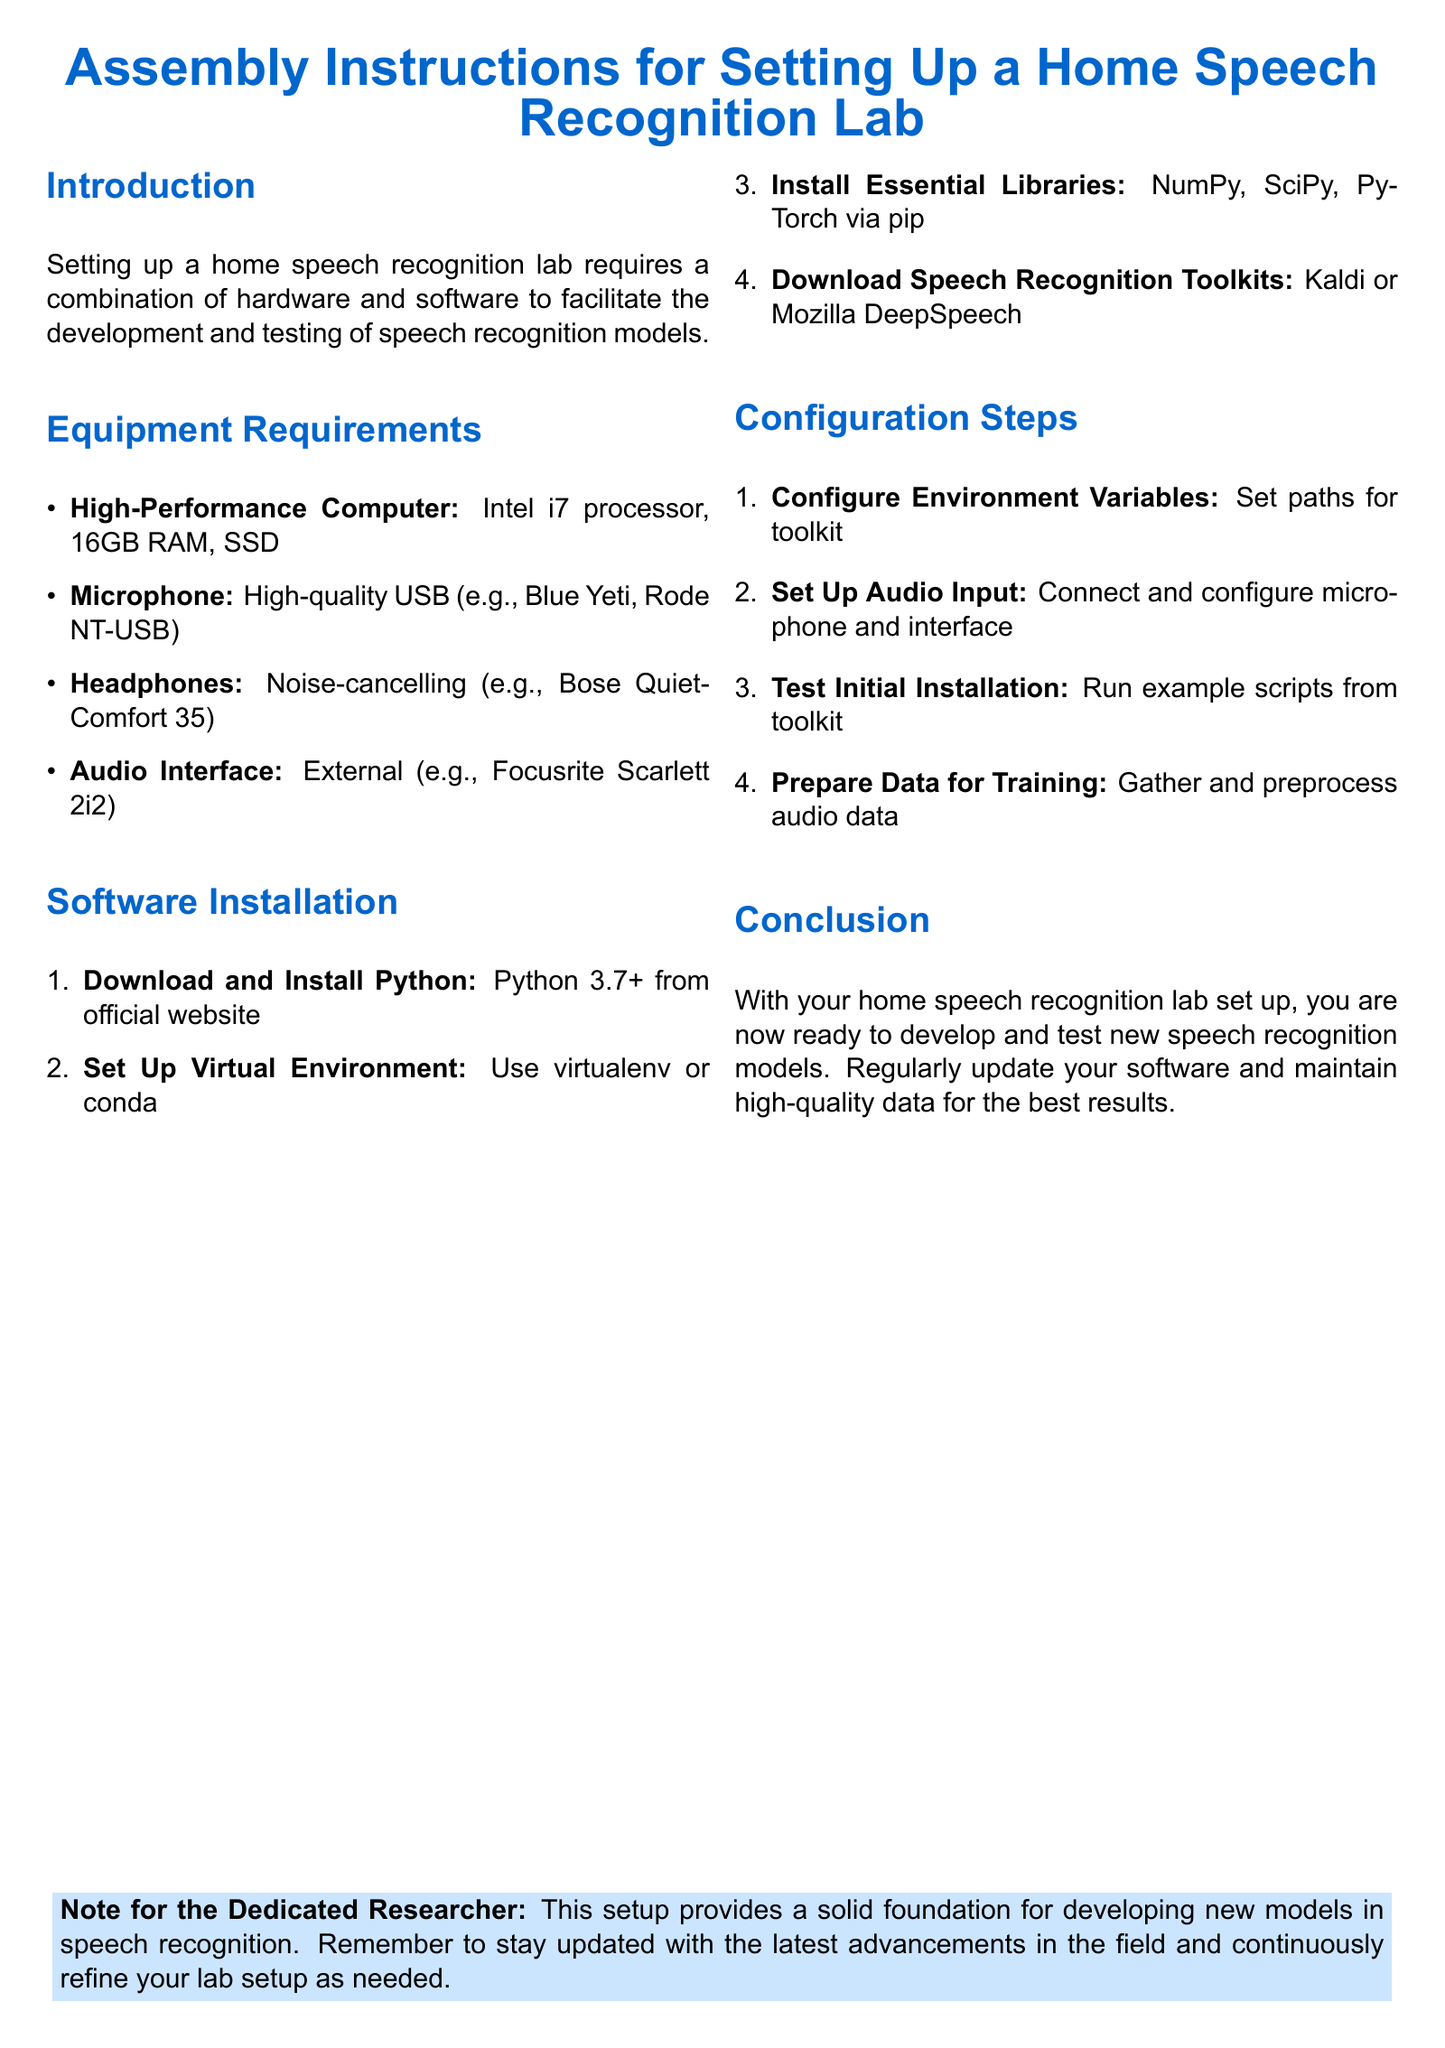What is the recommended processor for the computer? The document lists the processor requirement as Intel i7.
Answer: Intel i7 What type of microphone is suggested? The document mentions the use of a high-quality USB microphone such as Blue Yeti.
Answer: Blue Yeti How much RAM is required? The document specifies that 16GB of RAM is needed for the setup.
Answer: 16GB What version of Python is required? The document states that Python 3.7 or higher is needed.
Answer: 3.7+ Which audio interface is recommended? The document recommends Focusrite Scarlett 2i2 as an external audio interface.
Answer: Focusrite Scarlett 2i2 What is the first step in software installation? According to the document, the first step is to download and install Python.
Answer: Download and install Python What should you do to prepare data for training? The document instructs to gather and preprocess audio data.
Answer: Gather and preprocess audio data What is the purpose of setting environment variables? The document implies that setting paths for the toolkit is necessary during configuration.
Answer: Set paths for toolkit How many high-performance computer specifications are listed? There are four specifications listed for the high-performance computer in the document.
Answer: Four 